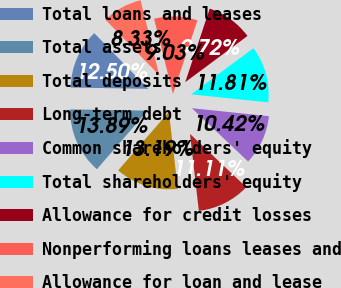Convert chart to OTSL. <chart><loc_0><loc_0><loc_500><loc_500><pie_chart><fcel>Total loans and leases<fcel>Total assets<fcel>Total deposits<fcel>Long-term debt<fcel>Common shareholders' equity<fcel>Total shareholders' equity<fcel>Allowance for credit losses<fcel>Nonperforming loans leases and<fcel>Allowance for loan and lease<nl><fcel>12.5%<fcel>13.89%<fcel>13.19%<fcel>11.11%<fcel>10.42%<fcel>11.81%<fcel>9.72%<fcel>9.03%<fcel>8.33%<nl></chart> 